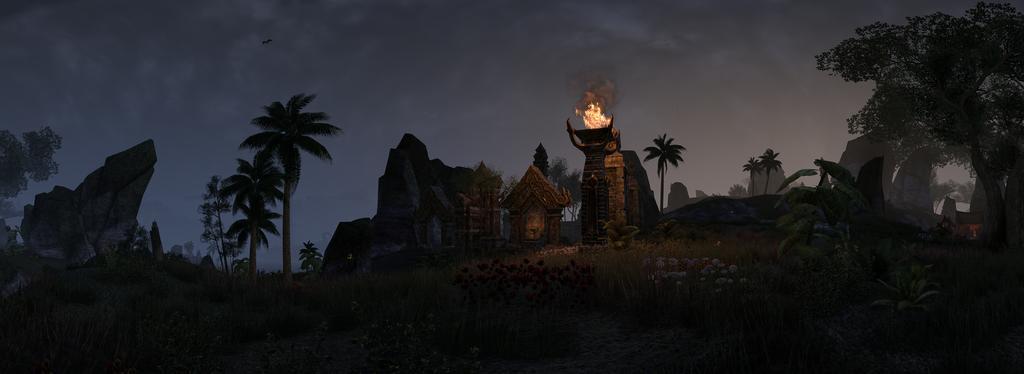How would you summarize this image in a sentence or two? In this image we can see rocks, trees, flowers, plants, also we can see fire on the pillar, there are sculptures, also we can see the sky. 